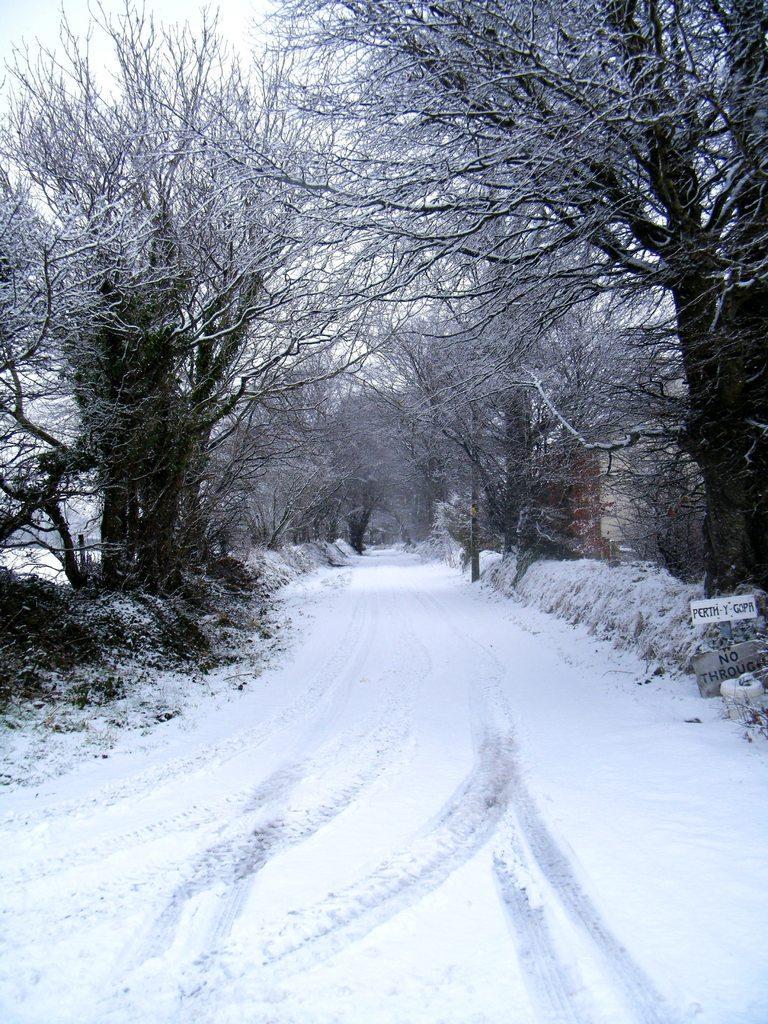Please provide a concise description of this image. In this image there are trees, snow, ski and boards. Something is written on the boards. Land is covered with snow. 